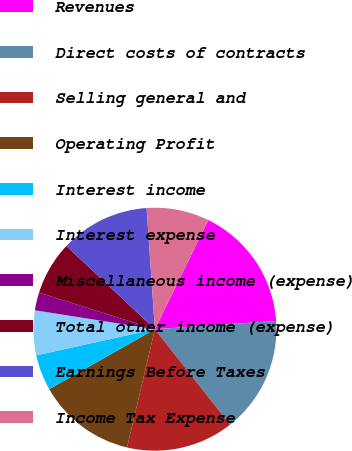<chart> <loc_0><loc_0><loc_500><loc_500><pie_chart><fcel>Revenues<fcel>Direct costs of contracts<fcel>Selling general and<fcel>Operating Profit<fcel>Interest income<fcel>Interest expense<fcel>Miscellaneous income (expense)<fcel>Total other income (expense)<fcel>Earnings Before Taxes<fcel>Income Tax Expense<nl><fcel>16.67%<fcel>15.48%<fcel>14.29%<fcel>13.1%<fcel>4.76%<fcel>5.95%<fcel>2.38%<fcel>7.14%<fcel>11.9%<fcel>8.33%<nl></chart> 